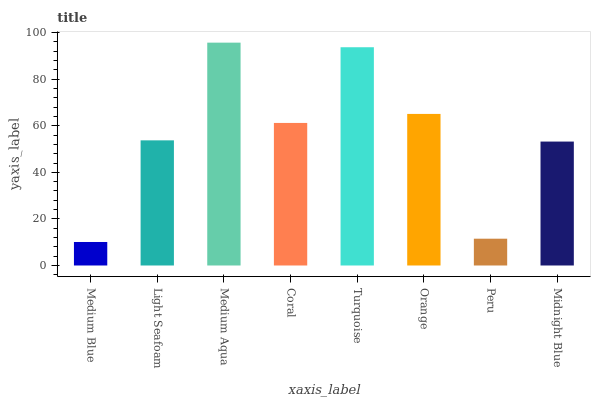Is Medium Blue the minimum?
Answer yes or no. Yes. Is Medium Aqua the maximum?
Answer yes or no. Yes. Is Light Seafoam the minimum?
Answer yes or no. No. Is Light Seafoam the maximum?
Answer yes or no. No. Is Light Seafoam greater than Medium Blue?
Answer yes or no. Yes. Is Medium Blue less than Light Seafoam?
Answer yes or no. Yes. Is Medium Blue greater than Light Seafoam?
Answer yes or no. No. Is Light Seafoam less than Medium Blue?
Answer yes or no. No. Is Coral the high median?
Answer yes or no. Yes. Is Light Seafoam the low median?
Answer yes or no. Yes. Is Midnight Blue the high median?
Answer yes or no. No. Is Medium Blue the low median?
Answer yes or no. No. 